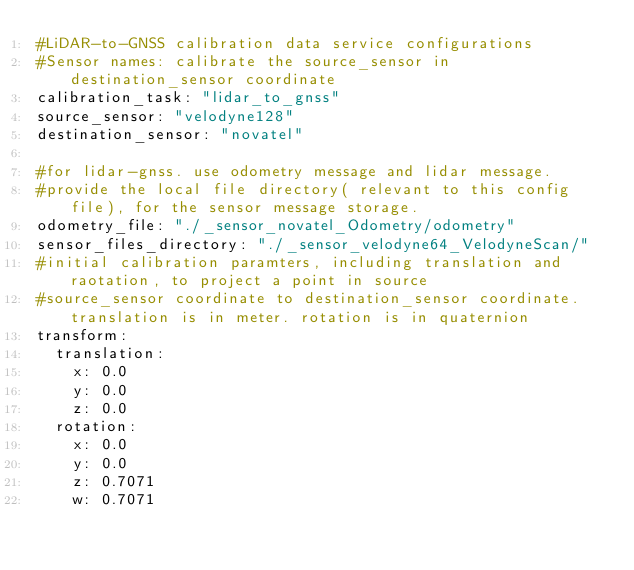Convert code to text. <code><loc_0><loc_0><loc_500><loc_500><_YAML_>#LiDAR-to-GNSS calibration data service configurations
#Sensor names: calibrate the source_sensor in destination_sensor coordinate
calibration_task: "lidar_to_gnss"
source_sensor: "velodyne128"
destination_sensor: "novatel"

#for lidar-gnss. use odometry message and lidar message.
#provide the local file directory( relevant to this config file), for the sensor message storage.
odometry_file: "./_sensor_novatel_Odometry/odometry"
sensor_files_directory: "./_sensor_velodyne64_VelodyneScan/"
#initial calibration paramters, including translation and raotation, to project a point in source
#source_sensor coordinate to destination_sensor coordinate. translation is in meter. rotation is in quaternion
transform:
  translation:
    x: 0.0
    y: 0.0
    z: 0.0
  rotation:
    x: 0.0
    y: 0.0
    z: 0.7071
    w: 0.7071
</code> 